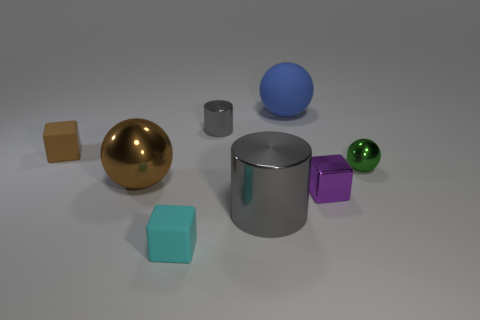Subtract all small metallic spheres. How many spheres are left? 2 Add 2 matte things. How many objects exist? 10 Subtract all purple blocks. How many blocks are left? 2 Subtract 1 cubes. How many cubes are left? 2 Subtract 0 yellow blocks. How many objects are left? 8 Subtract all balls. How many objects are left? 5 Subtract all cyan cylinders. Subtract all purple cubes. How many cylinders are left? 2 Subtract all big brown rubber cubes. Subtract all metal spheres. How many objects are left? 6 Add 6 gray shiny cylinders. How many gray shiny cylinders are left? 8 Add 7 blue things. How many blue things exist? 8 